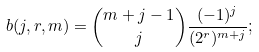Convert formula to latex. <formula><loc_0><loc_0><loc_500><loc_500>b ( j , r , m ) = \binom { m + j - 1 } { j } \frac { ( - 1 ) ^ { j } } { ( 2 ^ { r } ) ^ { m + j } } ;</formula> 